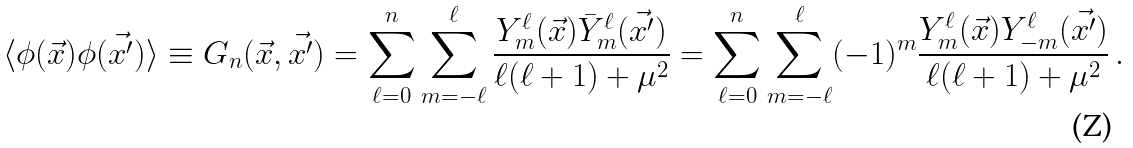<formula> <loc_0><loc_0><loc_500><loc_500>\langle \phi ( \vec { x } ) \phi ( \vec { x ^ { \prime } } ) \rangle \equiv G _ { n } ( \vec { x } , \vec { x ^ { \prime } } ) = \sum _ { \ell = 0 } ^ { n } \sum _ { m = - \ell } ^ { \ell } \frac { Y ^ { \ell } _ { m } ( \vec { x } ) \bar { Y } ^ { \ell } _ { m } ( \vec { x ^ { \prime } } ) } { \ell ( \ell + 1 ) + \mu ^ { 2 } } = \sum _ { \ell = 0 } ^ { n } \sum _ { m = - \ell } ^ { \ell } ( - 1 ) ^ { m } \frac { Y ^ { \ell } _ { m } ( \vec { x } ) Y ^ { \ell } _ { - m } ( \vec { x ^ { \prime } } ) } { \ell ( \ell + 1 ) + \mu ^ { 2 } } \, .</formula> 